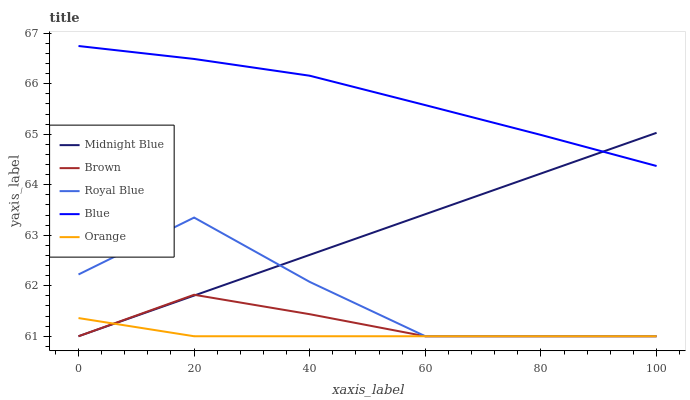Does Orange have the minimum area under the curve?
Answer yes or no. Yes. Does Blue have the maximum area under the curve?
Answer yes or no. Yes. Does Brown have the minimum area under the curve?
Answer yes or no. No. Does Brown have the maximum area under the curve?
Answer yes or no. No. Is Midnight Blue the smoothest?
Answer yes or no. Yes. Is Royal Blue the roughest?
Answer yes or no. Yes. Is Brown the smoothest?
Answer yes or no. No. Is Brown the roughest?
Answer yes or no. No. Does Brown have the lowest value?
Answer yes or no. Yes. Does Blue have the highest value?
Answer yes or no. Yes. Does Brown have the highest value?
Answer yes or no. No. Is Royal Blue less than Blue?
Answer yes or no. Yes. Is Blue greater than Royal Blue?
Answer yes or no. Yes. Does Midnight Blue intersect Royal Blue?
Answer yes or no. Yes. Is Midnight Blue less than Royal Blue?
Answer yes or no. No. Is Midnight Blue greater than Royal Blue?
Answer yes or no. No. Does Royal Blue intersect Blue?
Answer yes or no. No. 